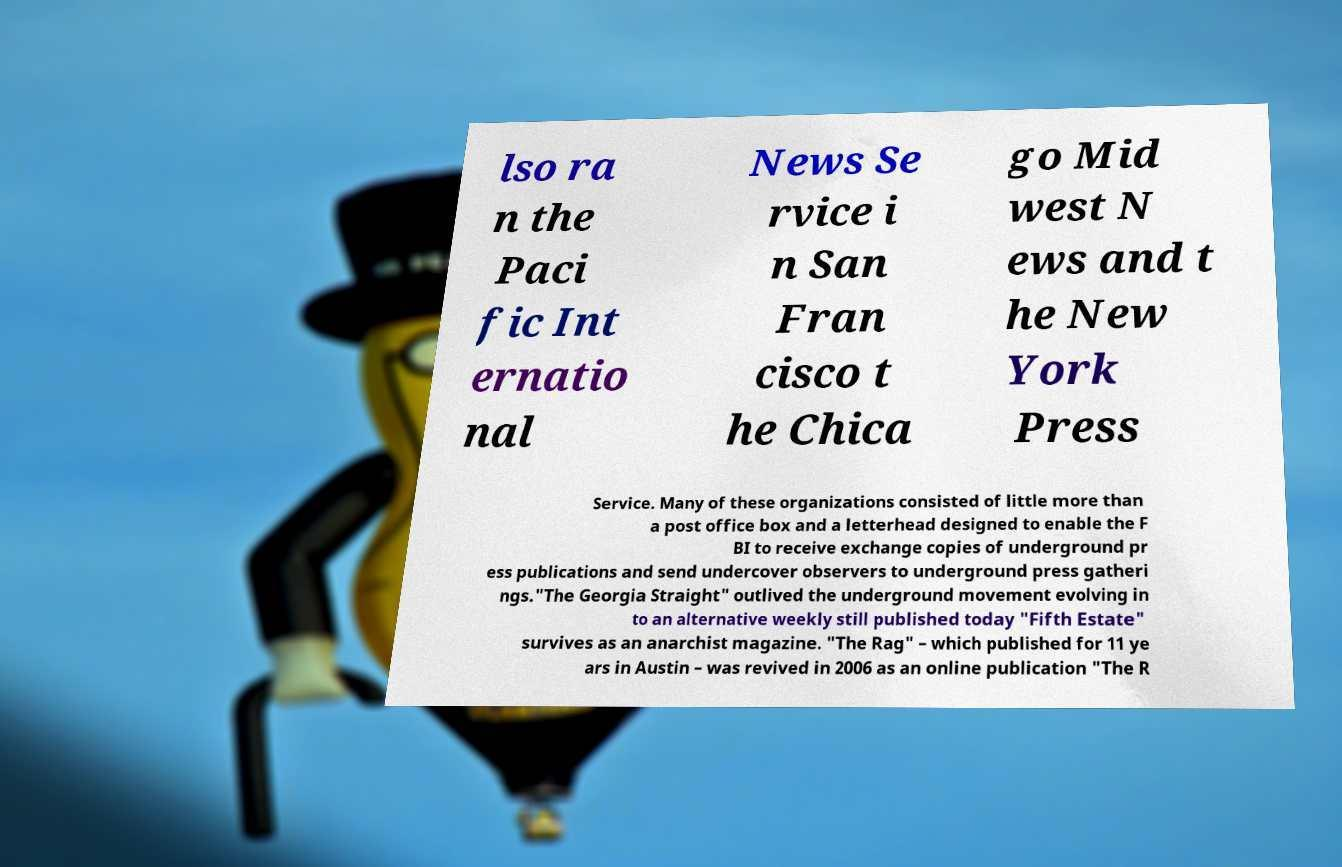There's text embedded in this image that I need extracted. Can you transcribe it verbatim? lso ra n the Paci fic Int ernatio nal News Se rvice i n San Fran cisco t he Chica go Mid west N ews and t he New York Press Service. Many of these organizations consisted of little more than a post office box and a letterhead designed to enable the F BI to receive exchange copies of underground pr ess publications and send undercover observers to underground press gatheri ngs."The Georgia Straight" outlived the underground movement evolving in to an alternative weekly still published today "Fifth Estate" survives as an anarchist magazine. "The Rag" – which published for 11 ye ars in Austin – was revived in 2006 as an online publication "The R 